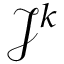<formula> <loc_0><loc_0><loc_500><loc_500>\mathcal { J } ^ { k }</formula> 